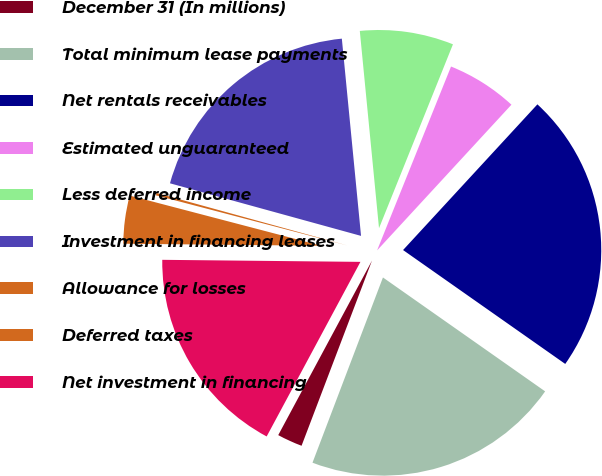Convert chart to OTSL. <chart><loc_0><loc_0><loc_500><loc_500><pie_chart><fcel>December 31 (In millions)<fcel>Total minimum lease payments<fcel>Net rentals receivables<fcel>Estimated unguaranteed<fcel>Less deferred income<fcel>Investment in financing leases<fcel>Allowance for losses<fcel>Deferred taxes<fcel>Net investment in financing<nl><fcel>2.06%<fcel>21.04%<fcel>22.89%<fcel>5.77%<fcel>7.63%<fcel>19.18%<fcel>0.2%<fcel>3.91%<fcel>17.32%<nl></chart> 